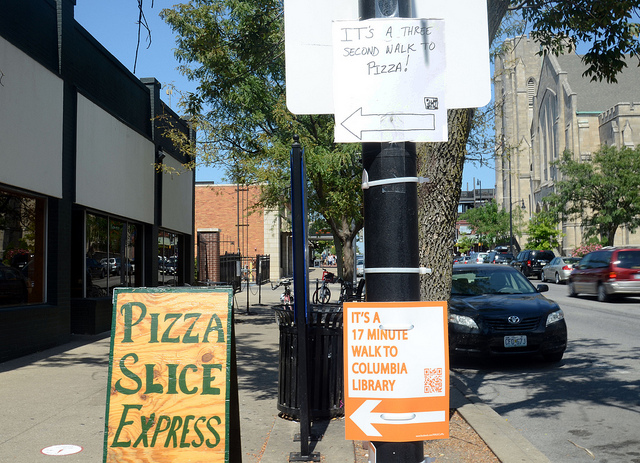Can you tell me more about the area shown in this image? What kind of neighborhood might this be? The image displays an urban street with a variety of signage, including directions to a library and an advertisement for a pizza express service. This suggests a community-oriented neighborhood with walkable amenities. The mix of services and directional signs indicates an area that caters to both local residents and visitors, potentially with a diverse array of shops, dining options, and public facilities within walking distance. 